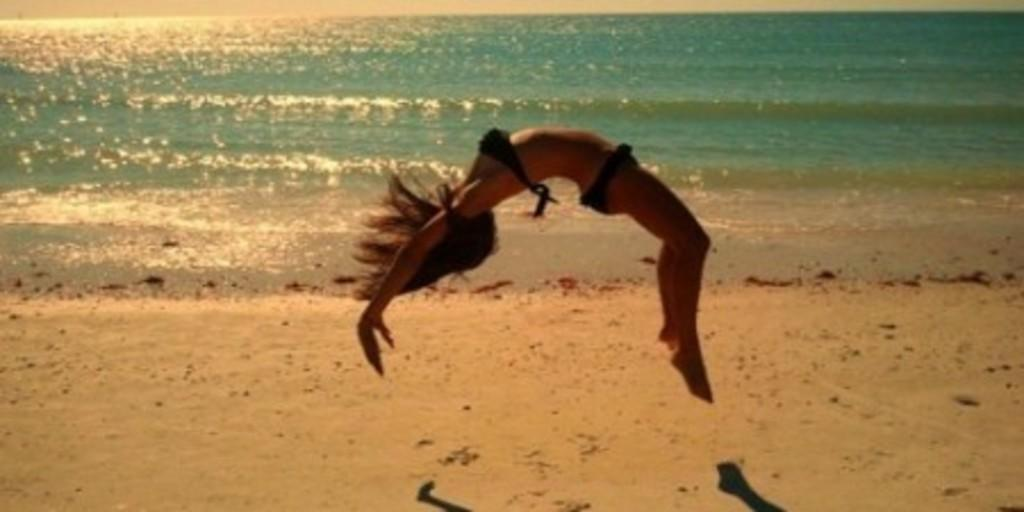Who is the main subject in the image? There is a lady in the image. What is the lady doing in the image? The lady is doing gymnastics in the image. What type of environment is depicted in the image? There is water and sand visible in the image, suggesting a beach or waterfront location. What type of cheese can be seen in the image? There is no cheese present in the image. How many sacks are visible in the image? There are no sacks present in the image. 